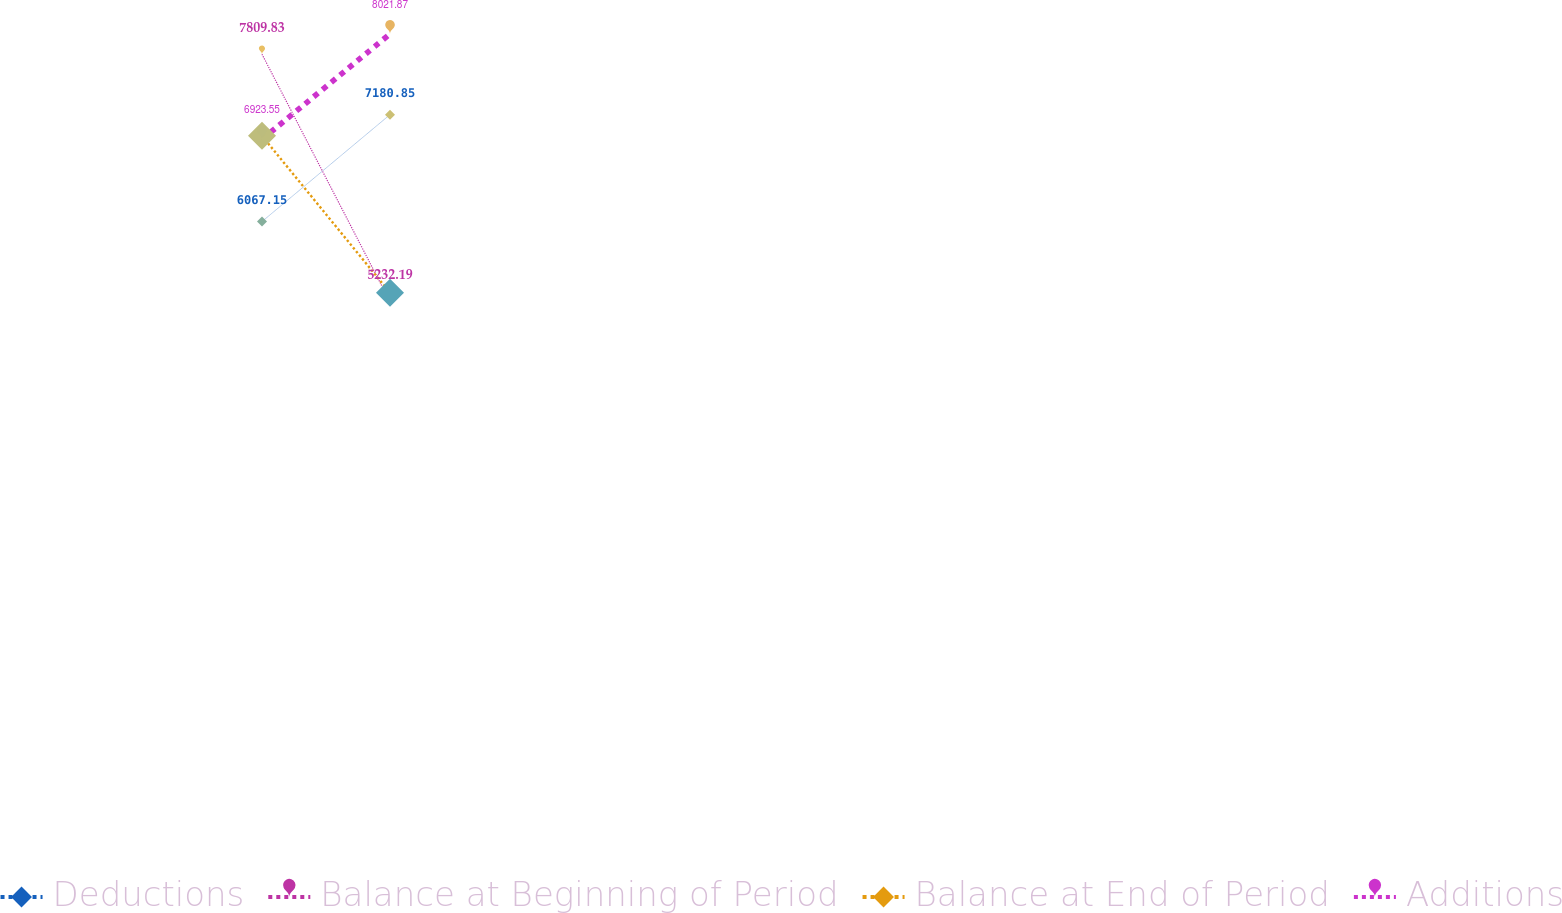<chart> <loc_0><loc_0><loc_500><loc_500><line_chart><ecel><fcel>Deductions<fcel>Balance at Beginning of Period<fcel>Balance at End of Period<fcel>Additions<nl><fcel>1840.1<fcel>6067.15<fcel>7809.83<fcel>6959.75<fcel>6923.55<nl><fcel>1871.4<fcel>7180.85<fcel>5232.19<fcel>5325.88<fcel>8021.87<nl><fcel>2153.06<fcel>10053.7<fcel>6934.75<fcel>8177.93<fcel>8825.55<nl></chart> 